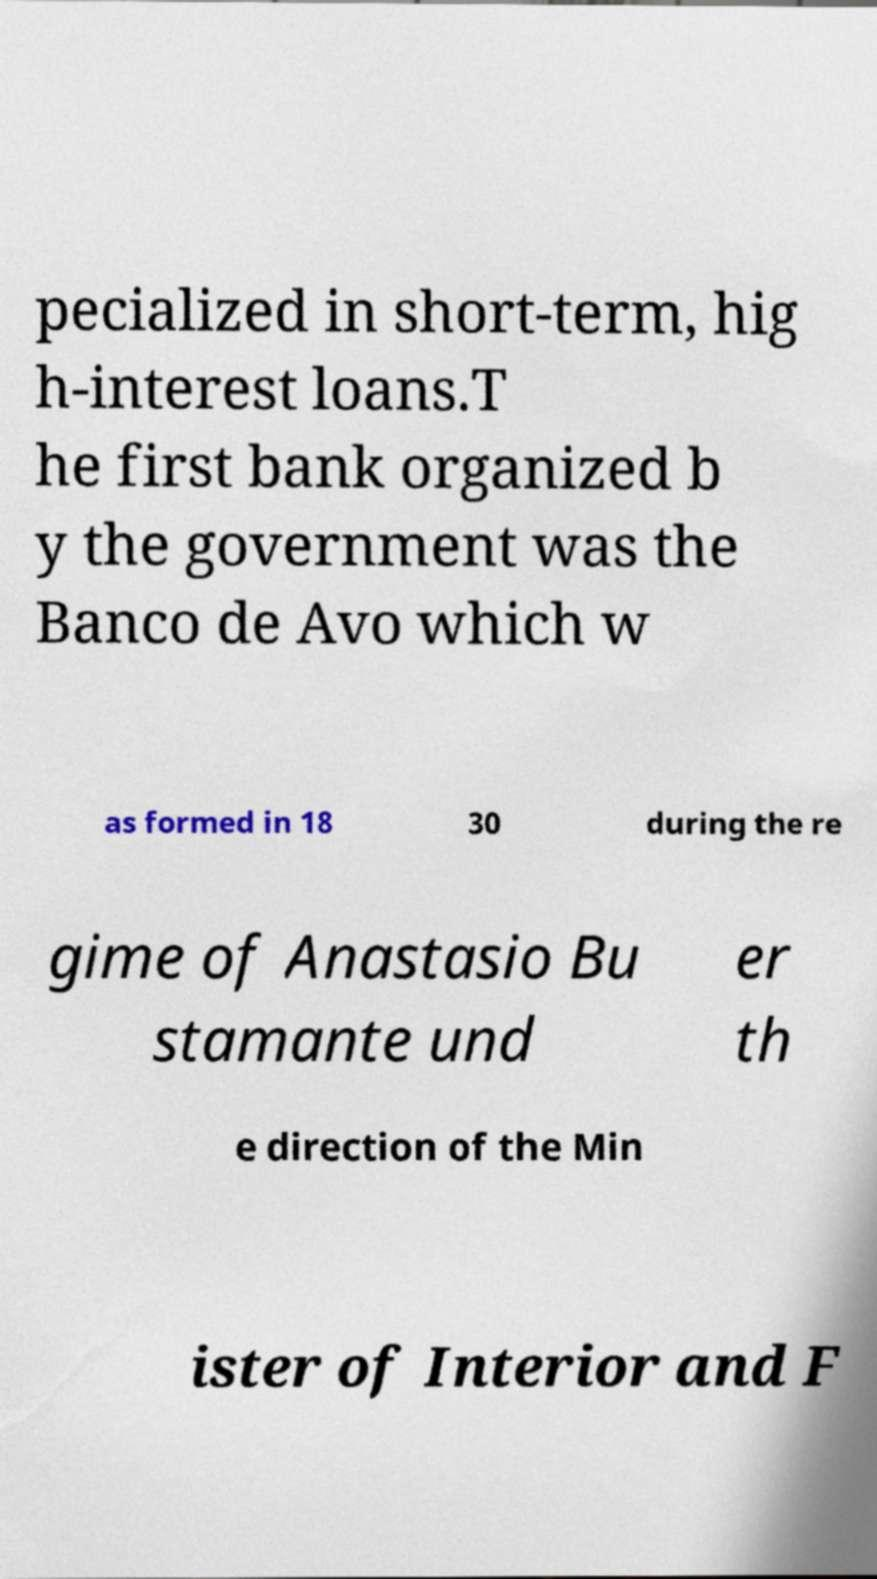Please identify and transcribe the text found in this image. pecialized in short-term, hig h-interest loans.T he first bank organized b y the government was the Banco de Avo which w as formed in 18 30 during the re gime of Anastasio Bu stamante und er th e direction of the Min ister of Interior and F 